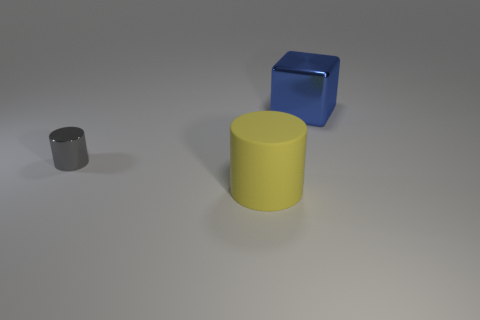Add 1 gray metallic cylinders. How many objects exist? 4 Subtract all cylinders. How many objects are left? 1 Add 1 green matte cylinders. How many green matte cylinders exist? 1 Subtract 1 gray cylinders. How many objects are left? 2 Subtract all brown cylinders. Subtract all brown blocks. How many cylinders are left? 2 Subtract all blue things. Subtract all small red objects. How many objects are left? 2 Add 1 tiny gray metallic cylinders. How many tiny gray metallic cylinders are left? 2 